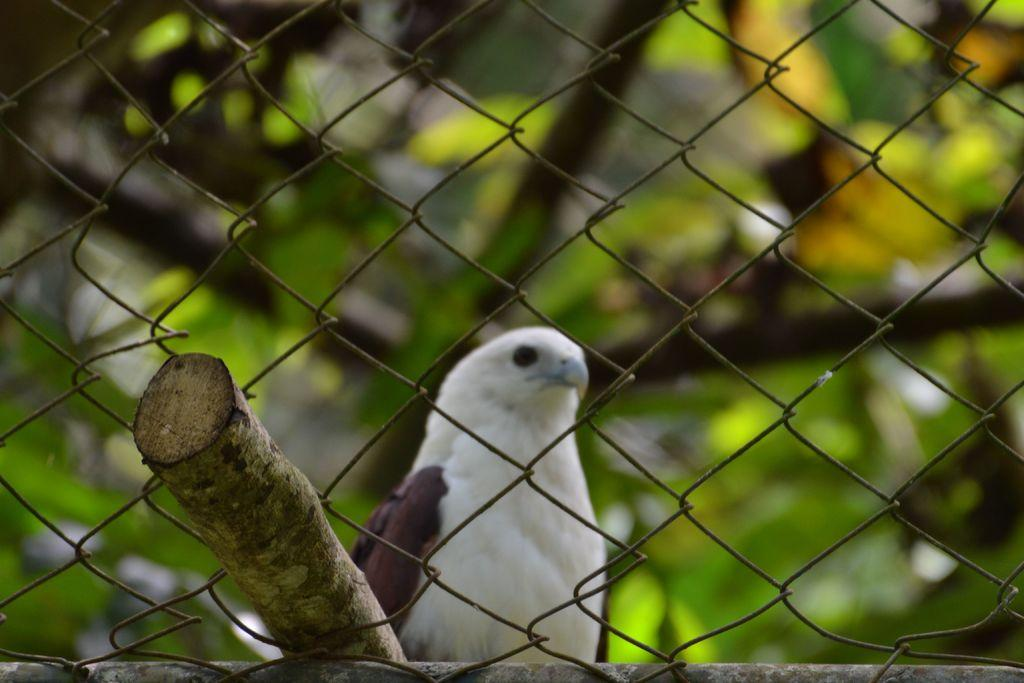What type of animal can be seen in the image? There is a bird in the image. What object is present in the image alongside the bird? There is a stick in the image. What type of structure is visible in the image? There is fencing in the image. What type of vegetation is present in the image? There are plants in the image. How would you describe the background of the image? The background of the image is blurred. How many snails are crawling on the bird in the image? There are no snails present in the image; it only features a bird, a stick, fencing, plants, and a blurred background. 